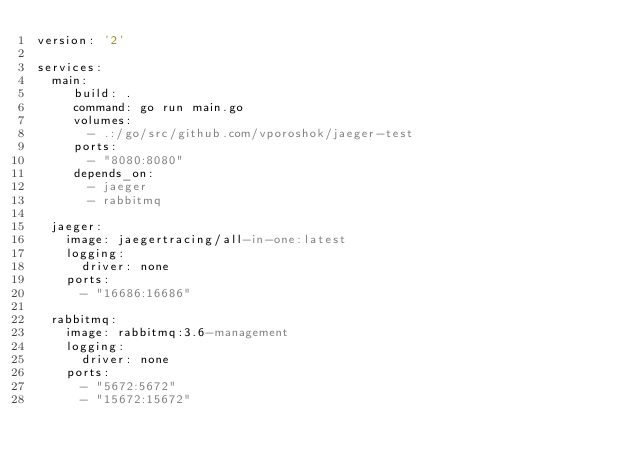Convert code to text. <code><loc_0><loc_0><loc_500><loc_500><_YAML_>version: '2'

services:
  main:
     build: .
     command: go run main.go
     volumes:
       - .:/go/src/github.com/vporoshok/jaeger-test
     ports:
       - "8080:8080"
     depends_on:
       - jaeger
       - rabbitmq

  jaeger:
    image: jaegertracing/all-in-one:latest
    logging:
      driver: none
    ports:
      - "16686:16686"

  rabbitmq:
    image: rabbitmq:3.6-management
    logging:
      driver: none
    ports:
      - "5672:5672"
      - "15672:15672"
</code> 